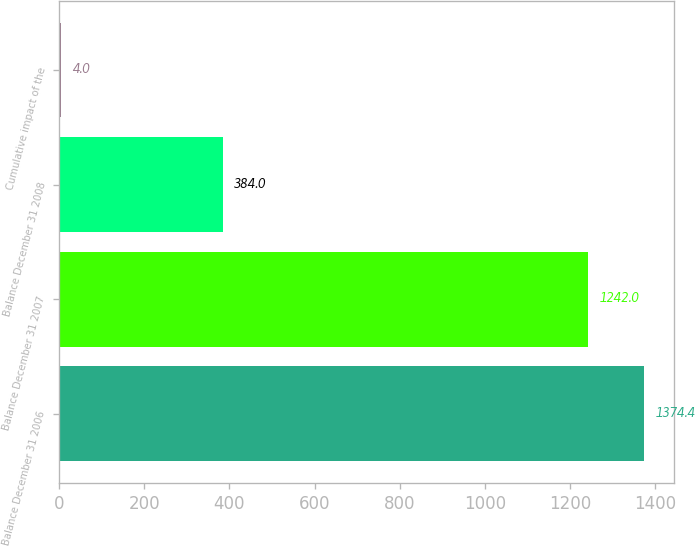Convert chart to OTSL. <chart><loc_0><loc_0><loc_500><loc_500><bar_chart><fcel>Balance December 31 2006<fcel>Balance December 31 2007<fcel>Balance December 31 2008<fcel>Cumulative impact of the<nl><fcel>1374.4<fcel>1242<fcel>384<fcel>4<nl></chart> 